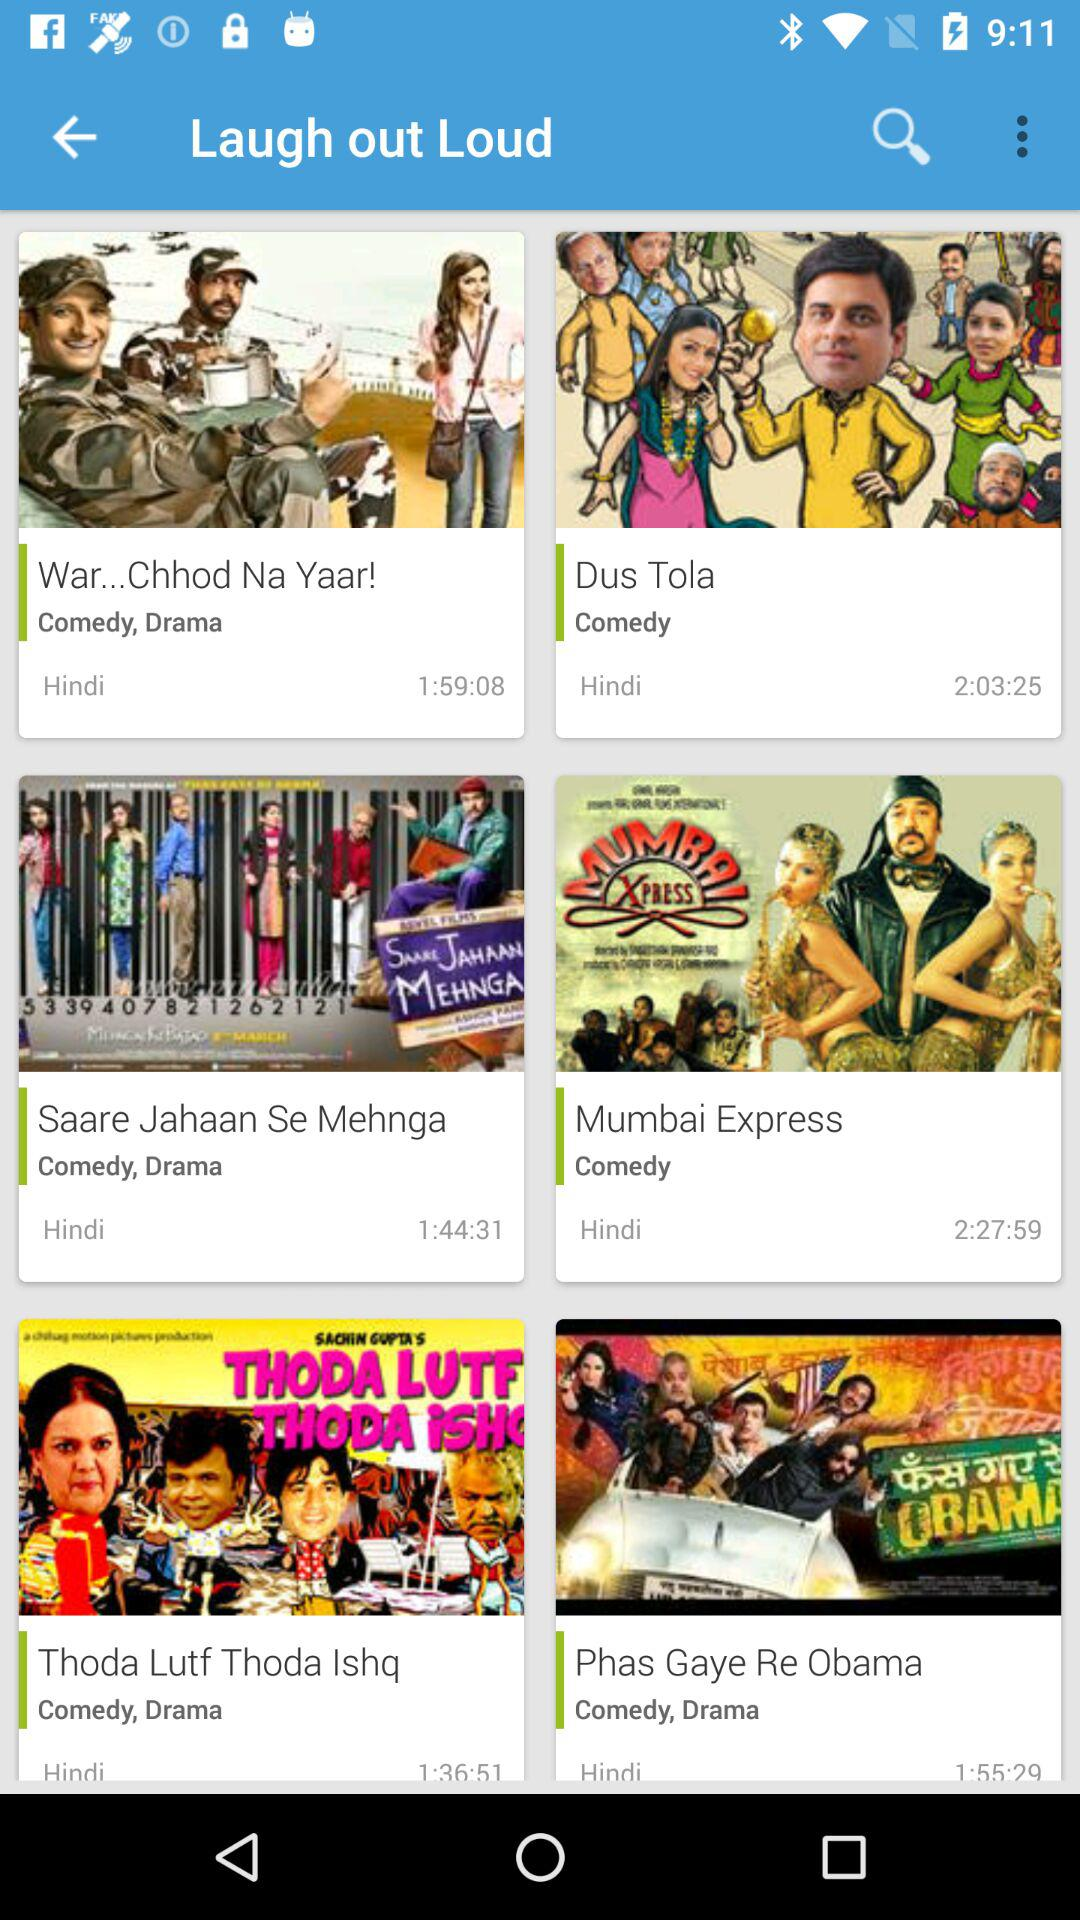Which item has the longest runtime?
Answer the question using a single word or phrase. Mumbai Express 